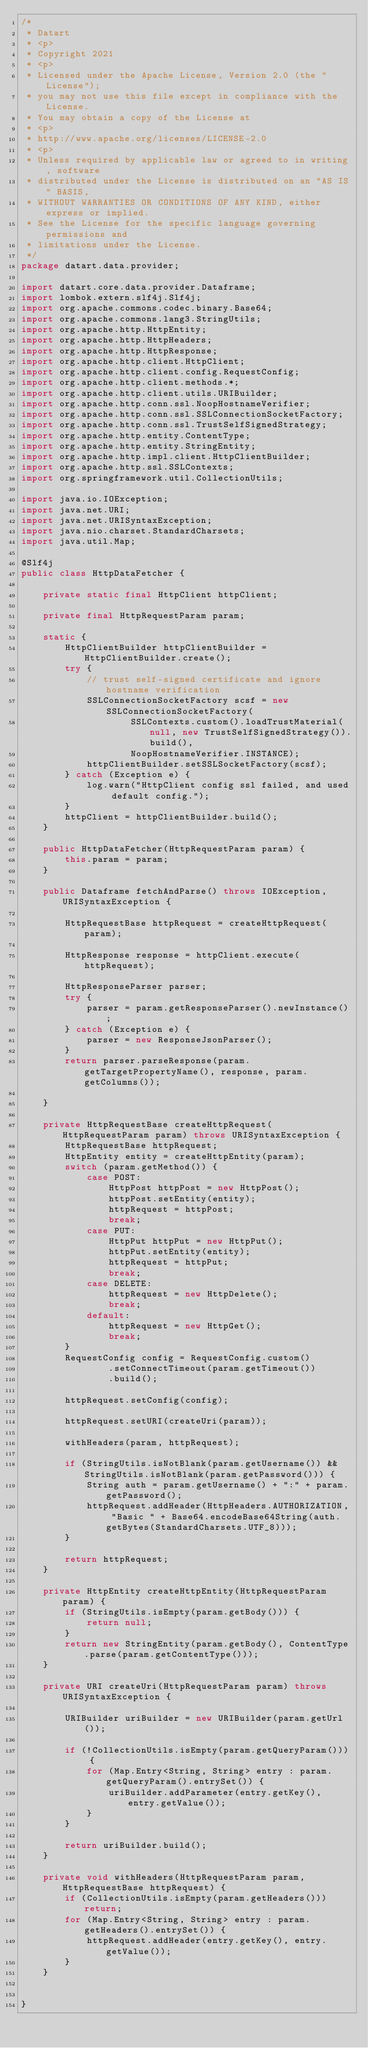<code> <loc_0><loc_0><loc_500><loc_500><_Java_>/*
 * Datart
 * <p>
 * Copyright 2021
 * <p>
 * Licensed under the Apache License, Version 2.0 (the "License");
 * you may not use this file except in compliance with the License.
 * You may obtain a copy of the License at
 * <p>
 * http://www.apache.org/licenses/LICENSE-2.0
 * <p>
 * Unless required by applicable law or agreed to in writing, software
 * distributed under the License is distributed on an "AS IS" BASIS,
 * WITHOUT WARRANTIES OR CONDITIONS OF ANY KIND, either express or implied.
 * See the License for the specific language governing permissions and
 * limitations under the License.
 */
package datart.data.provider;

import datart.core.data.provider.Dataframe;
import lombok.extern.slf4j.Slf4j;
import org.apache.commons.codec.binary.Base64;
import org.apache.commons.lang3.StringUtils;
import org.apache.http.HttpEntity;
import org.apache.http.HttpHeaders;
import org.apache.http.HttpResponse;
import org.apache.http.client.HttpClient;
import org.apache.http.client.config.RequestConfig;
import org.apache.http.client.methods.*;
import org.apache.http.client.utils.URIBuilder;
import org.apache.http.conn.ssl.NoopHostnameVerifier;
import org.apache.http.conn.ssl.SSLConnectionSocketFactory;
import org.apache.http.conn.ssl.TrustSelfSignedStrategy;
import org.apache.http.entity.ContentType;
import org.apache.http.entity.StringEntity;
import org.apache.http.impl.client.HttpClientBuilder;
import org.apache.http.ssl.SSLContexts;
import org.springframework.util.CollectionUtils;

import java.io.IOException;
import java.net.URI;
import java.net.URISyntaxException;
import java.nio.charset.StandardCharsets;
import java.util.Map;

@Slf4j
public class HttpDataFetcher {

    private static final HttpClient httpClient;

    private final HttpRequestParam param;

    static {
        HttpClientBuilder httpClientBuilder = HttpClientBuilder.create();
        try {
            // trust self-signed certificate and ignore hostname verification
            SSLConnectionSocketFactory scsf = new SSLConnectionSocketFactory(
                    SSLContexts.custom().loadTrustMaterial(null, new TrustSelfSignedStrategy()).build(),
                    NoopHostnameVerifier.INSTANCE);
            httpClientBuilder.setSSLSocketFactory(scsf);
        } catch (Exception e) {
            log.warn("HttpClient config ssl failed, and used default config.");
        }
        httpClient = httpClientBuilder.build();
    }

    public HttpDataFetcher(HttpRequestParam param) {
        this.param = param;
    }

    public Dataframe fetchAndParse() throws IOException, URISyntaxException {

        HttpRequestBase httpRequest = createHttpRequest(param);

        HttpResponse response = httpClient.execute(httpRequest);

        HttpResponseParser parser;
        try {
            parser = param.getResponseParser().newInstance();
        } catch (Exception e) {
            parser = new ResponseJsonParser();
        }
        return parser.parseResponse(param.getTargetPropertyName(), response, param.getColumns());

    }

    private HttpRequestBase createHttpRequest(HttpRequestParam param) throws URISyntaxException {
        HttpRequestBase httpRequest;
        HttpEntity entity = createHttpEntity(param);
        switch (param.getMethod()) {
            case POST:
                HttpPost httpPost = new HttpPost();
                httpPost.setEntity(entity);
                httpRequest = httpPost;
                break;
            case PUT:
                HttpPut httpPut = new HttpPut();
                httpPut.setEntity(entity);
                httpRequest = httpPut;
                break;
            case DELETE:
                httpRequest = new HttpDelete();
                break;
            default:
                httpRequest = new HttpGet();
                break;
        }
        RequestConfig config = RequestConfig.custom()
                .setConnectTimeout(param.getTimeout())
                .build();

        httpRequest.setConfig(config);

        httpRequest.setURI(createUri(param));

        withHeaders(param, httpRequest);

        if (StringUtils.isNotBlank(param.getUsername()) && StringUtils.isNotBlank(param.getPassword())) {
            String auth = param.getUsername() + ":" + param.getPassword();
            httpRequest.addHeader(HttpHeaders.AUTHORIZATION, "Basic " + Base64.encodeBase64String(auth.getBytes(StandardCharsets.UTF_8)));
        }

        return httpRequest;
    }

    private HttpEntity createHttpEntity(HttpRequestParam param) {
        if (StringUtils.isEmpty(param.getBody())) {
            return null;
        }
        return new StringEntity(param.getBody(), ContentType.parse(param.getContentType()));
    }

    private URI createUri(HttpRequestParam param) throws URISyntaxException {

        URIBuilder uriBuilder = new URIBuilder(param.getUrl());

        if (!CollectionUtils.isEmpty(param.getQueryParam())) {
            for (Map.Entry<String, String> entry : param.getQueryParam().entrySet()) {
                uriBuilder.addParameter(entry.getKey(), entry.getValue());
            }
        }

        return uriBuilder.build();
    }

    private void withHeaders(HttpRequestParam param, HttpRequestBase httpRequest) {
        if (CollectionUtils.isEmpty(param.getHeaders())) return;
        for (Map.Entry<String, String> entry : param.getHeaders().entrySet()) {
            httpRequest.addHeader(entry.getKey(), entry.getValue());
        }
    }


}</code> 